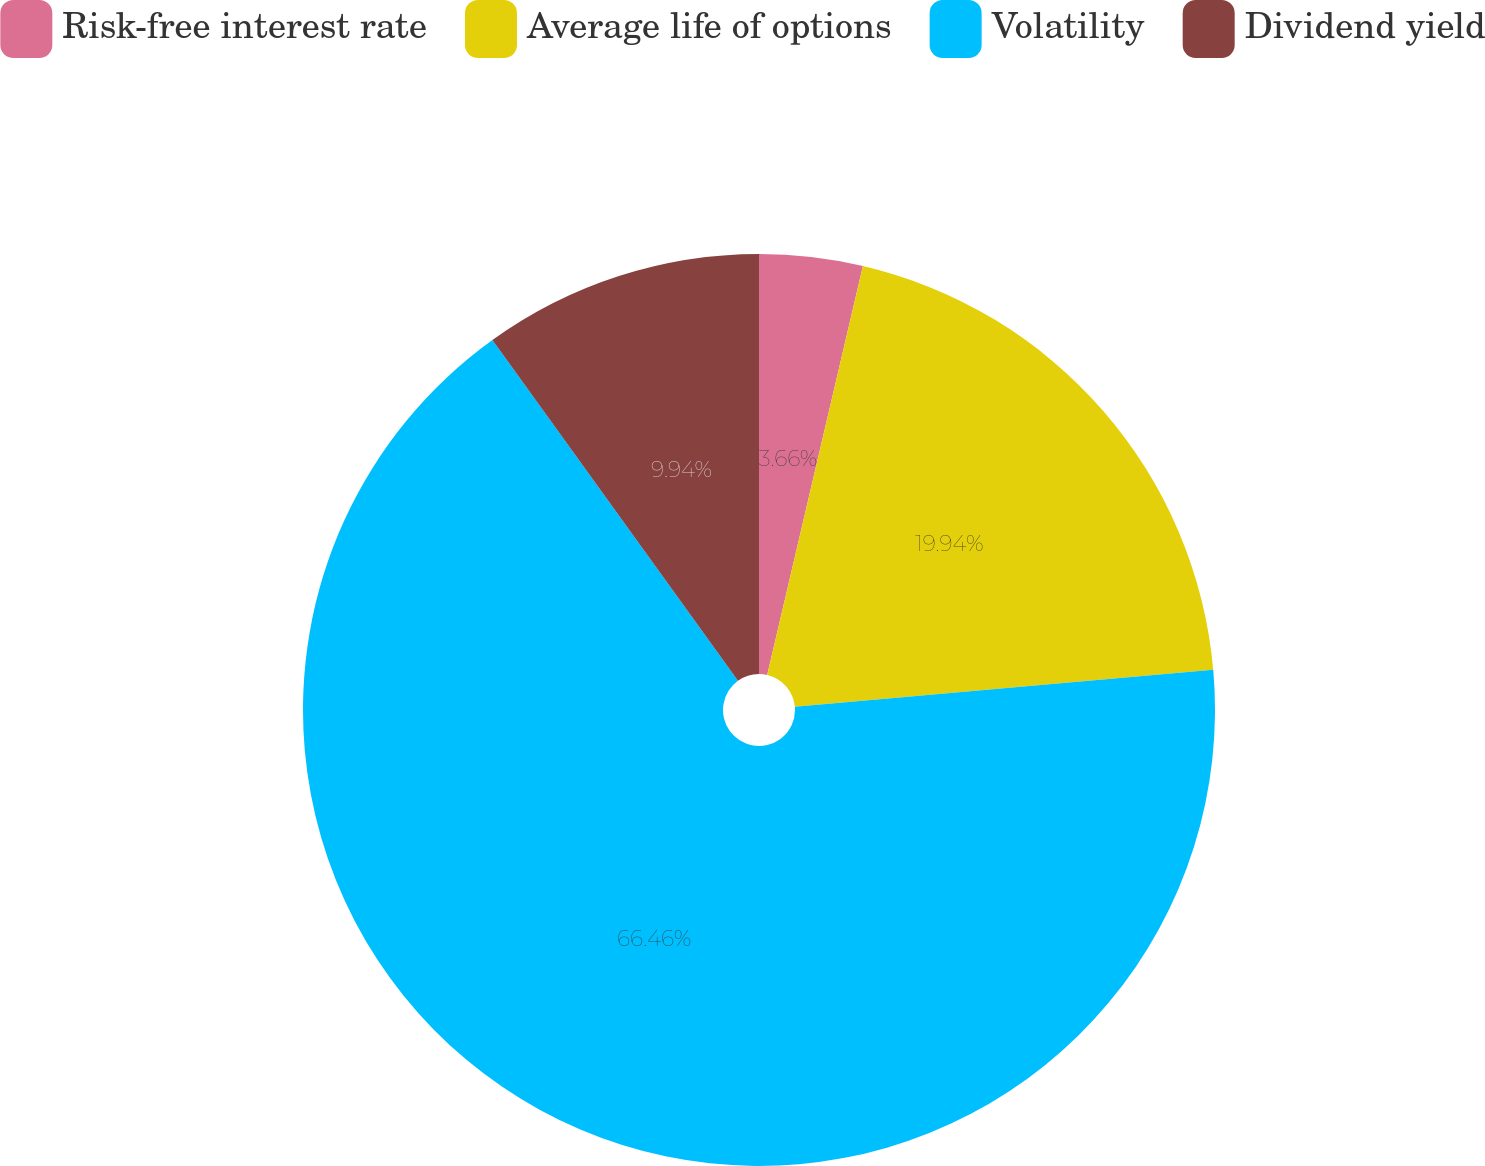Convert chart to OTSL. <chart><loc_0><loc_0><loc_500><loc_500><pie_chart><fcel>Risk-free interest rate<fcel>Average life of options<fcel>Volatility<fcel>Dividend yield<nl><fcel>3.66%<fcel>19.94%<fcel>66.47%<fcel>9.94%<nl></chart> 